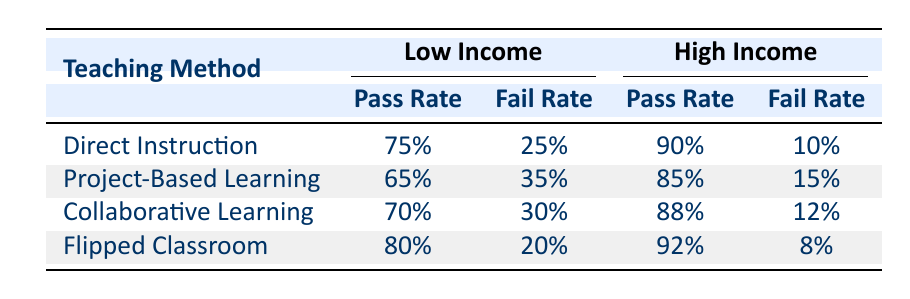What is the pass rate for students from low-income demographics using Project-Based Learning? According to the table, the pass rate for Project-Based Learning with low-income students is listed directly next to the corresponding teaching method, which is 65%.
Answer: 65% What is the fail rate for high-income students using Direct Instruction? The table shows that the fail rate for high-income students under Direct Instruction is specifically noted as 10%.
Answer: 10% Which teaching method has the highest pass rate for low-income students? By comparing the pass rates listed for low-income students across all teaching methods, Flipped Classroom has the highest pass rate at 80%, while Direct Instruction follows with 75%, Collaborative Learning with 70%, and Project-Based Learning with 65%.
Answer: Flipped Classroom Is the pass rate for High Income using Collaborative Learning higher than that for Project-Based Learning? The pass rate for High Income students using Collaborative Learning is 88%, and for Project-Based Learning, it is 85%. Since 88% is greater than 85%, the statement is true.
Answer: Yes What is the average pass rate for low-income students across all teaching methods? To find the average pass rate, sum the pass rates for low-income students: 75% (Direct Instruction) + 65% (Project-Based Learning) + 70% (Collaborative Learning) + 80% (Flipped Classroom) = 290%. Then, divide by the number of teaching methods (4): 290% / 4 = 72.5%.
Answer: 72.5% What is the difference in pass rates between High Income students in the Flipped Classroom and Direct Instruction? The pass rate for High Income students in the Flipped Classroom is 92%, and for Direct Instruction, it is 90%. The difference is calculated as 92% - 90% = 2%.
Answer: 2% Are all Low-Income teaching methods above 60% pass rate? The pass rates for low-income students are 75% (Direct Instruction), 65% (Project-Based Learning), 70% (Collaborative Learning), and 80% (Flipped Classroom). All these rates are above 60%, so the statement is true.
Answer: Yes Which income demographic achieved a lower fail rate for Project-Based Learning? The fail rate for low-income students is 35%, while the fail rate for high-income students is 15%. Since 15% is lower than 35%, high-income students achieved the lower fail rate for this method.
Answer: High Income What is the combined pass rate from the Collaborative Learning method for both demographics? Adding the pass rates: 70% (Low Income) + 88% (High Income) results in a total of 158%. To find the combined pass rate, divide by 2: 158% / 2 = 79%.
Answer: 79% 